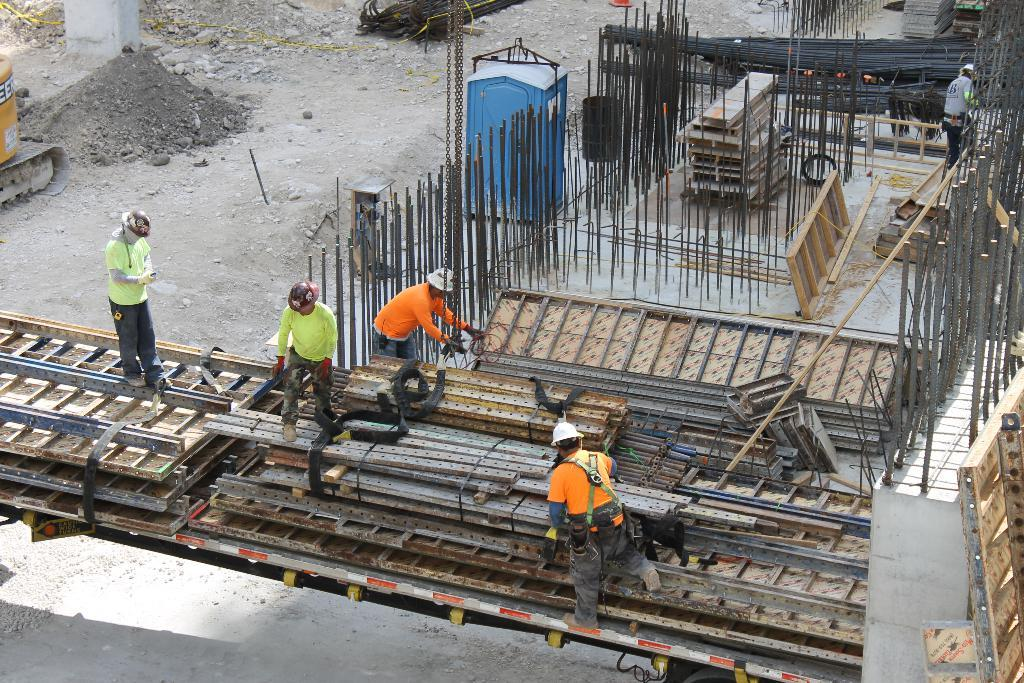What is the main subject of the image? The main subject of the image is a building under construction. What are the people in the image doing? The people in the image are working on the construction site. What type of toys can be seen scattered around the construction site in the image? There are no toys present in the image; it features a building under construction and people working on the site. 